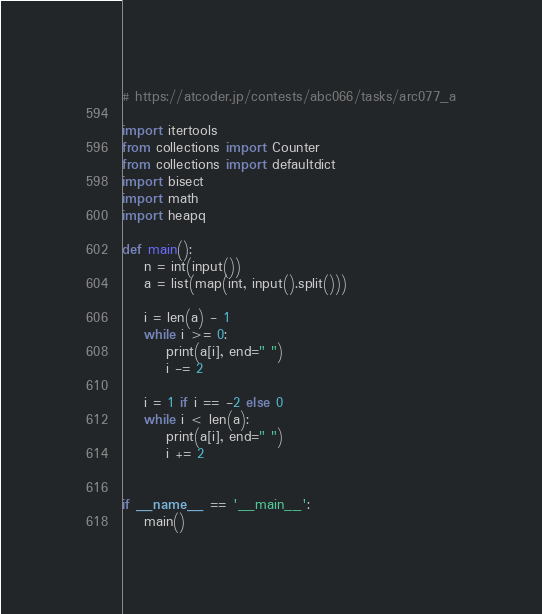<code> <loc_0><loc_0><loc_500><loc_500><_Python_># https://atcoder.jp/contests/abc066/tasks/arc077_a

import itertools
from collections import Counter
from collections import defaultdict
import bisect
import math
import heapq

def main():
    n = int(input())
    a = list(map(int, input().split()))

    i = len(a) - 1
    while i >= 0:
        print(a[i], end=" ")
        i -= 2

    i = 1 if i == -2 else 0
    while i < len(a):
        print(a[i], end=" ")
        i += 2


if __name__ == '__main__':
    main()
</code> 